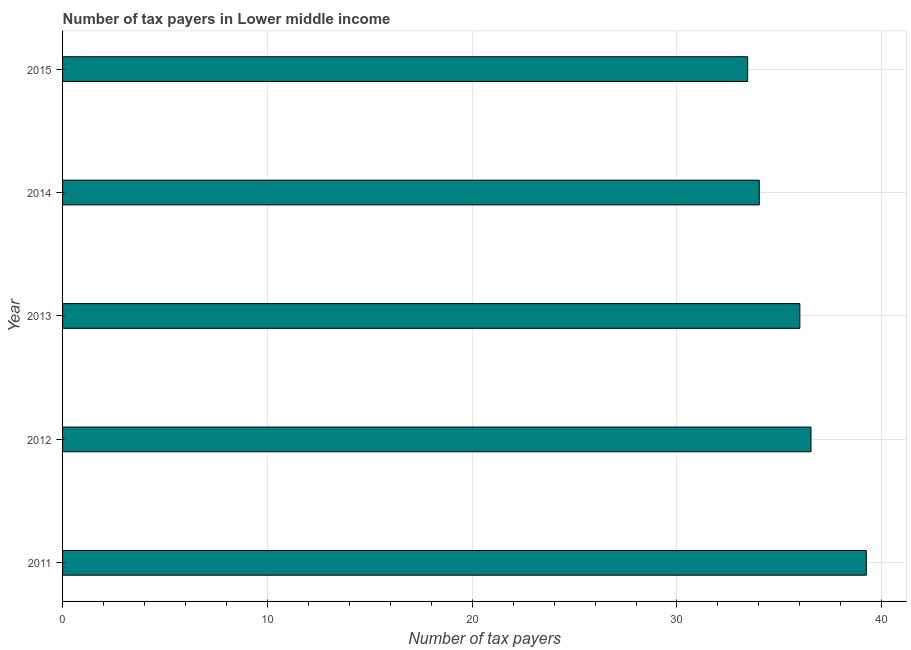Does the graph contain grids?
Ensure brevity in your answer.  Yes. What is the title of the graph?
Your answer should be compact. Number of tax payers in Lower middle income. What is the label or title of the X-axis?
Make the answer very short. Number of tax payers. What is the label or title of the Y-axis?
Make the answer very short. Year. What is the number of tax payers in 2015?
Give a very brief answer. 33.45. Across all years, what is the maximum number of tax payers?
Your answer should be compact. 39.24. Across all years, what is the minimum number of tax payers?
Your response must be concise. 33.45. In which year was the number of tax payers maximum?
Ensure brevity in your answer.  2011. In which year was the number of tax payers minimum?
Make the answer very short. 2015. What is the sum of the number of tax payers?
Your response must be concise. 179.26. What is the difference between the number of tax payers in 2011 and 2012?
Your answer should be compact. 2.7. What is the average number of tax payers per year?
Make the answer very short. 35.85. Do a majority of the years between 2015 and 2012 (inclusive) have number of tax payers greater than 8 ?
Make the answer very short. Yes. What is the ratio of the number of tax payers in 2011 to that in 2012?
Your answer should be compact. 1.07. Is the number of tax payers in 2011 less than that in 2012?
Make the answer very short. No. Is the difference between the number of tax payers in 2012 and 2015 greater than the difference between any two years?
Keep it short and to the point. No. What is the difference between the highest and the second highest number of tax payers?
Provide a succinct answer. 2.7. Is the sum of the number of tax payers in 2011 and 2012 greater than the maximum number of tax payers across all years?
Offer a terse response. Yes. What is the difference between the highest and the lowest number of tax payers?
Provide a short and direct response. 5.79. How many bars are there?
Your answer should be compact. 5. What is the Number of tax payers in 2011?
Your response must be concise. 39.24. What is the Number of tax payers in 2012?
Give a very brief answer. 36.54. What is the Number of tax payers in 2014?
Your answer should be very brief. 34.02. What is the Number of tax payers of 2015?
Make the answer very short. 33.45. What is the difference between the Number of tax payers in 2011 and 2012?
Your answer should be compact. 2.7. What is the difference between the Number of tax payers in 2011 and 2013?
Provide a succinct answer. 3.24. What is the difference between the Number of tax payers in 2011 and 2014?
Provide a short and direct response. 5.22. What is the difference between the Number of tax payers in 2011 and 2015?
Your answer should be compact. 5.79. What is the difference between the Number of tax payers in 2012 and 2013?
Your response must be concise. 0.54. What is the difference between the Number of tax payers in 2012 and 2014?
Give a very brief answer. 2.52. What is the difference between the Number of tax payers in 2012 and 2015?
Offer a very short reply. 3.09. What is the difference between the Number of tax payers in 2013 and 2014?
Your response must be concise. 1.98. What is the difference between the Number of tax payers in 2013 and 2015?
Ensure brevity in your answer.  2.55. What is the difference between the Number of tax payers in 2014 and 2015?
Give a very brief answer. 0.57. What is the ratio of the Number of tax payers in 2011 to that in 2012?
Ensure brevity in your answer.  1.07. What is the ratio of the Number of tax payers in 2011 to that in 2013?
Offer a very short reply. 1.09. What is the ratio of the Number of tax payers in 2011 to that in 2014?
Make the answer very short. 1.15. What is the ratio of the Number of tax payers in 2011 to that in 2015?
Offer a very short reply. 1.17. What is the ratio of the Number of tax payers in 2012 to that in 2014?
Your answer should be very brief. 1.07. What is the ratio of the Number of tax payers in 2012 to that in 2015?
Provide a short and direct response. 1.09. What is the ratio of the Number of tax payers in 2013 to that in 2014?
Provide a short and direct response. 1.06. What is the ratio of the Number of tax payers in 2013 to that in 2015?
Ensure brevity in your answer.  1.08. 